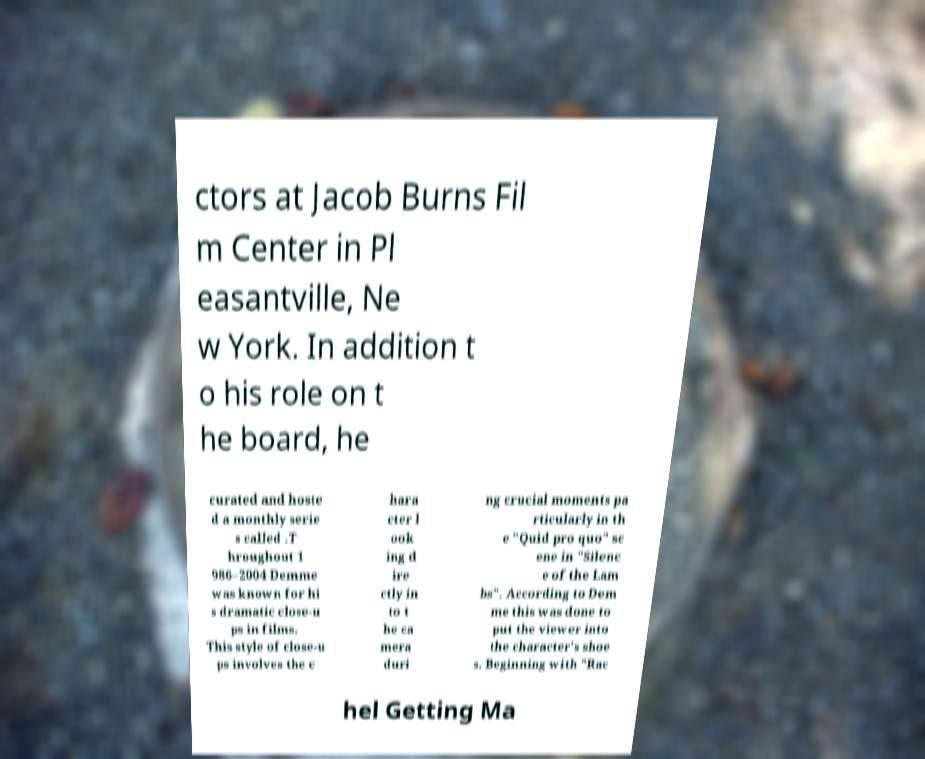Could you extract and type out the text from this image? ctors at Jacob Burns Fil m Center in Pl easantville, Ne w York. In addition t o his role on t he board, he curated and hoste d a monthly serie s called .T hroughout 1 986–2004 Demme was known for hi s dramatic close-u ps in films. This style of close-u ps involves the c hara cter l ook ing d ire ctly in to t he ca mera duri ng crucial moments pa rticularly in th e "Quid pro quo" sc ene in "Silenc e of the Lam bs". According to Dem me this was done to put the viewer into the character's shoe s. Beginning with "Rac hel Getting Ma 